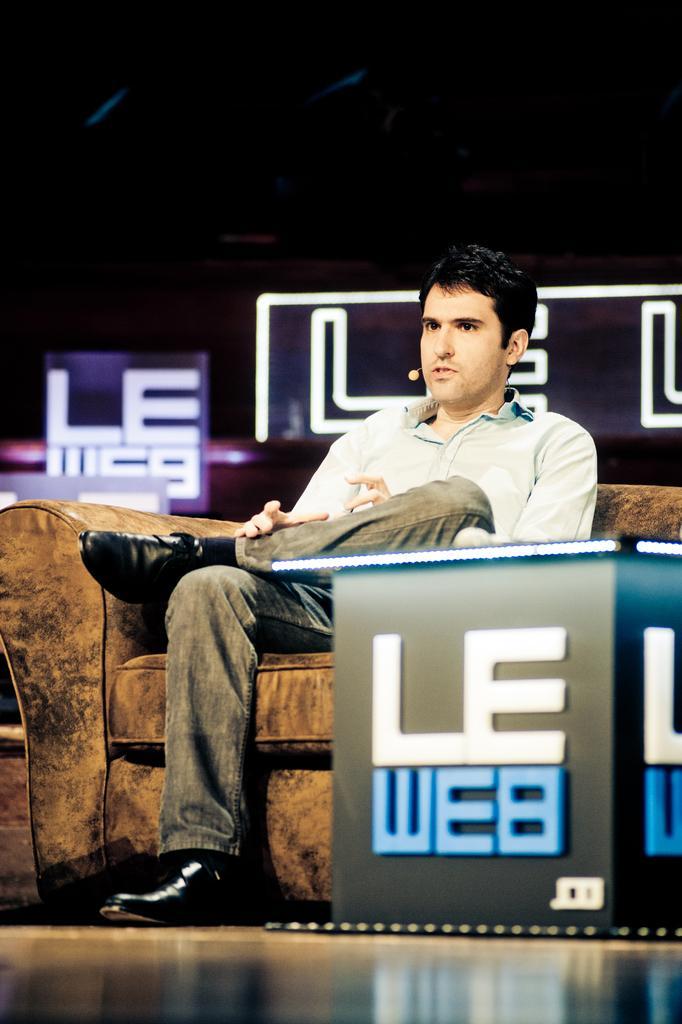How would you summarize this image in a sentence or two? In this image we can see a person wearing microphone is sitting on a sofa placed on the ground. To the right side of the image we can see a table with some text and some lights. In the background, we can see a sign board. 